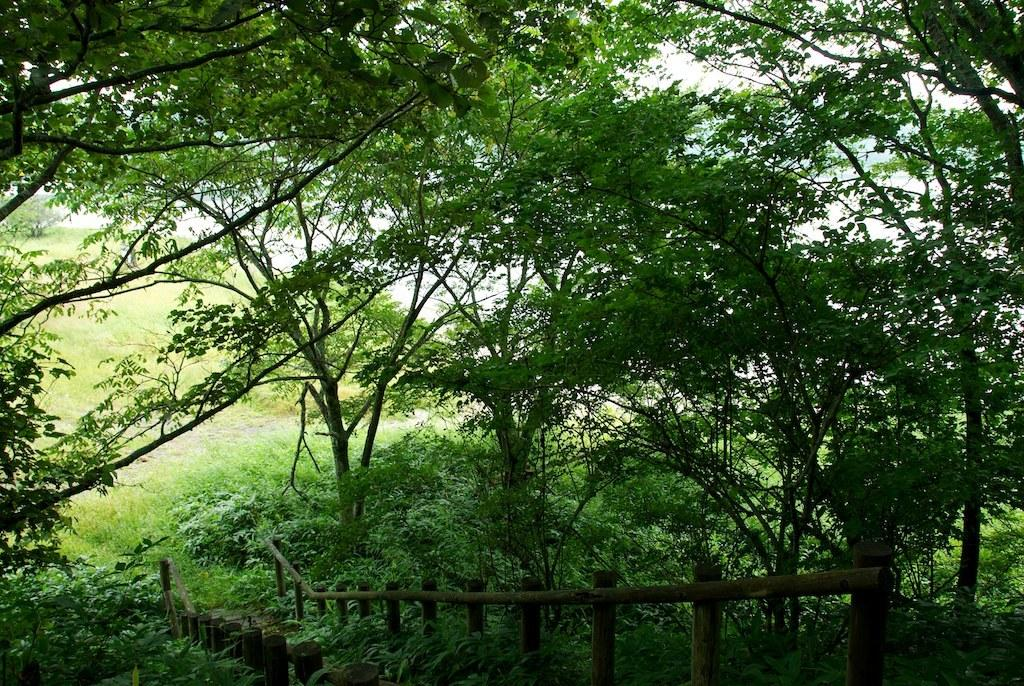What type of natural feature is present in the image? There is a group of trees in the image. What man-made structure can be seen in the image? There is a bridge in the image. Where is the bridge located in relation to the trees? The bridge is situated between the trees. Can you tell me how many kitties are playing on the bridge in the image? There are no kitties present in the image; it features a group of trees and a bridge. What type of transportation is visible on the bridge in the image? There is no transportation visible on the bridge in the image. 